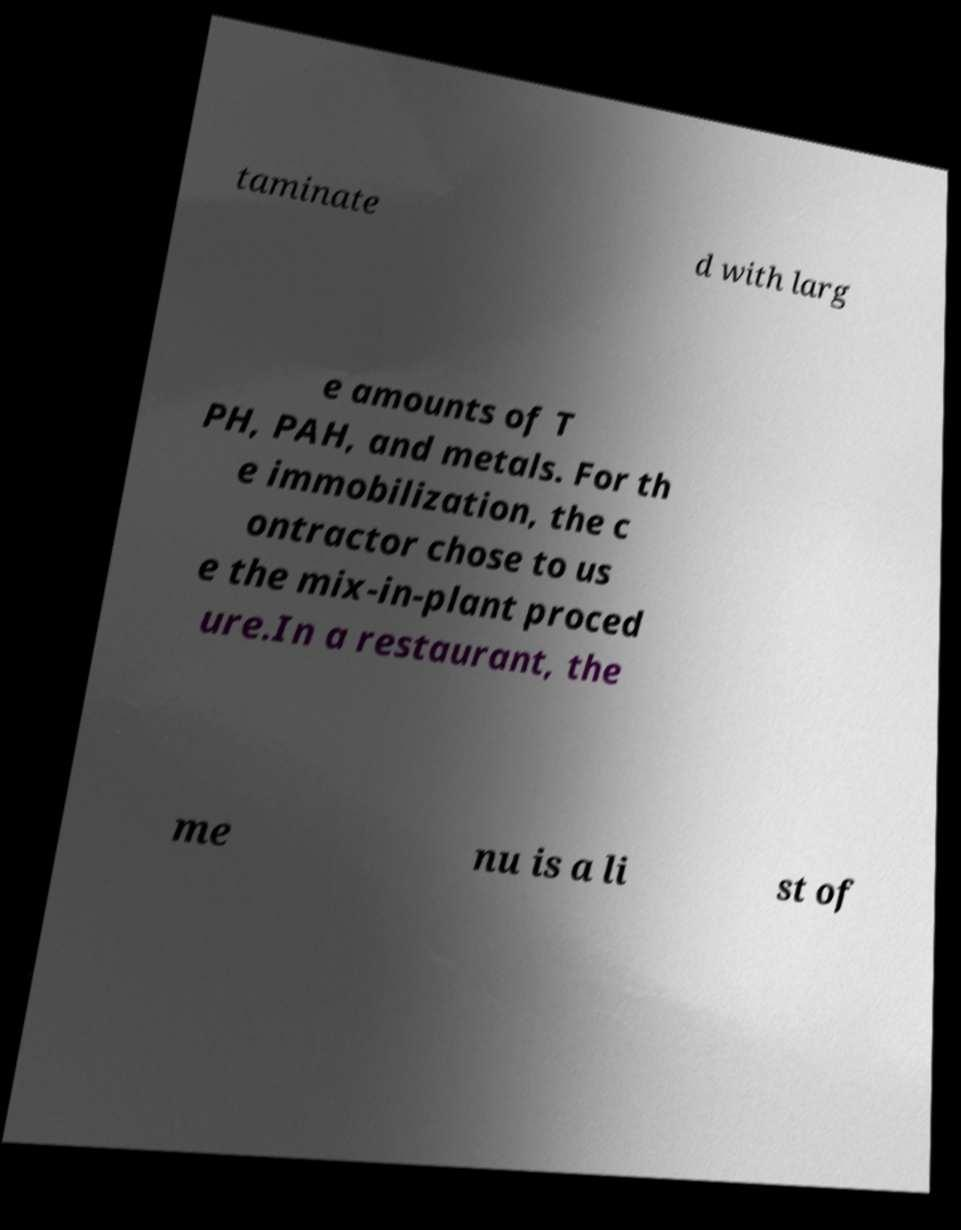For documentation purposes, I need the text within this image transcribed. Could you provide that? taminate d with larg e amounts of T PH, PAH, and metals. For th e immobilization, the c ontractor chose to us e the mix-in-plant proced ure.In a restaurant, the me nu is a li st of 